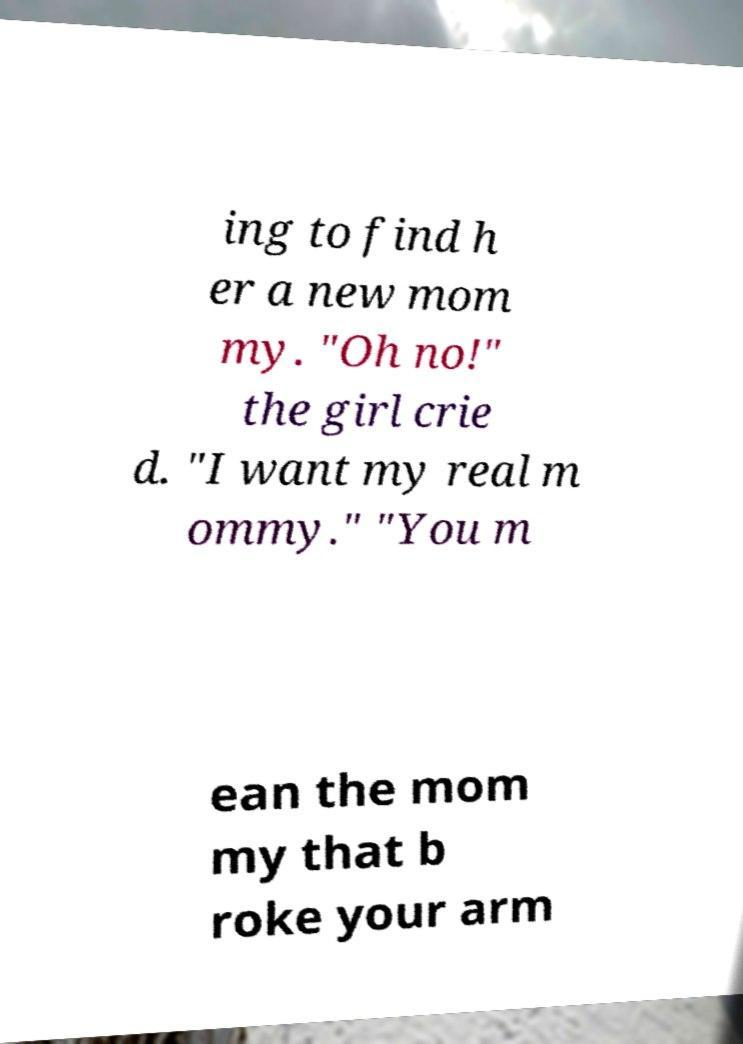Please identify and transcribe the text found in this image. ing to find h er a new mom my. "Oh no!" the girl crie d. "I want my real m ommy." "You m ean the mom my that b roke your arm 